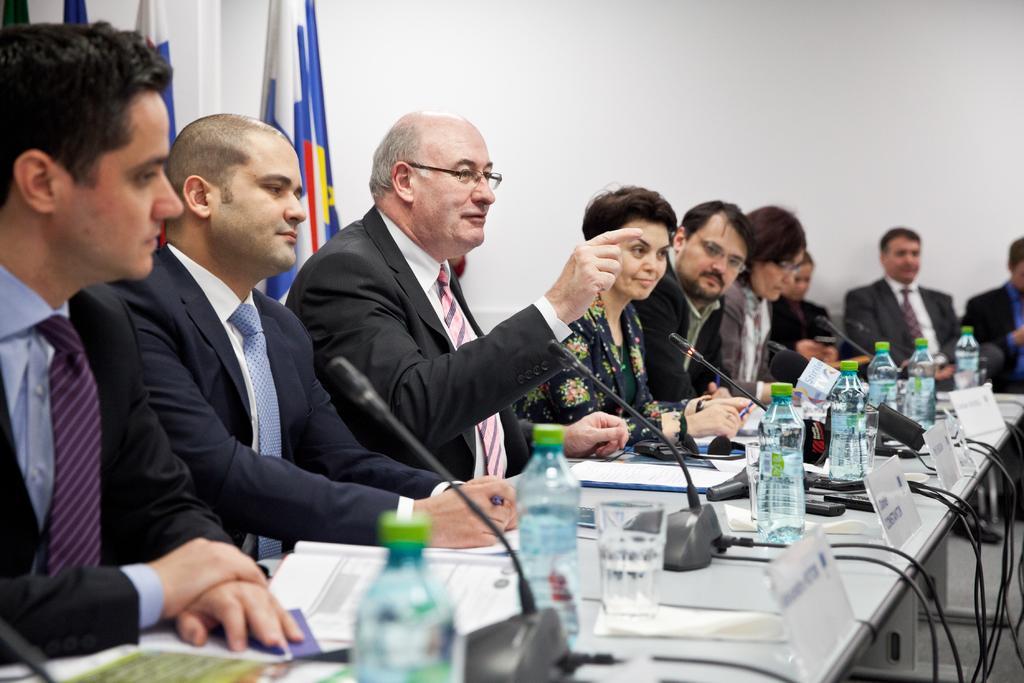Please provide a concise description of this image. There are group of people sitting in a line, in front of a table. Everyone is having microphone in front of them. On the table there are water bottles, name plates and papers. Some of them are holding pens. Everyone is wearing a coat. There are men and women in the group. Behind them we can observe flags. And in the background there is a wall. 